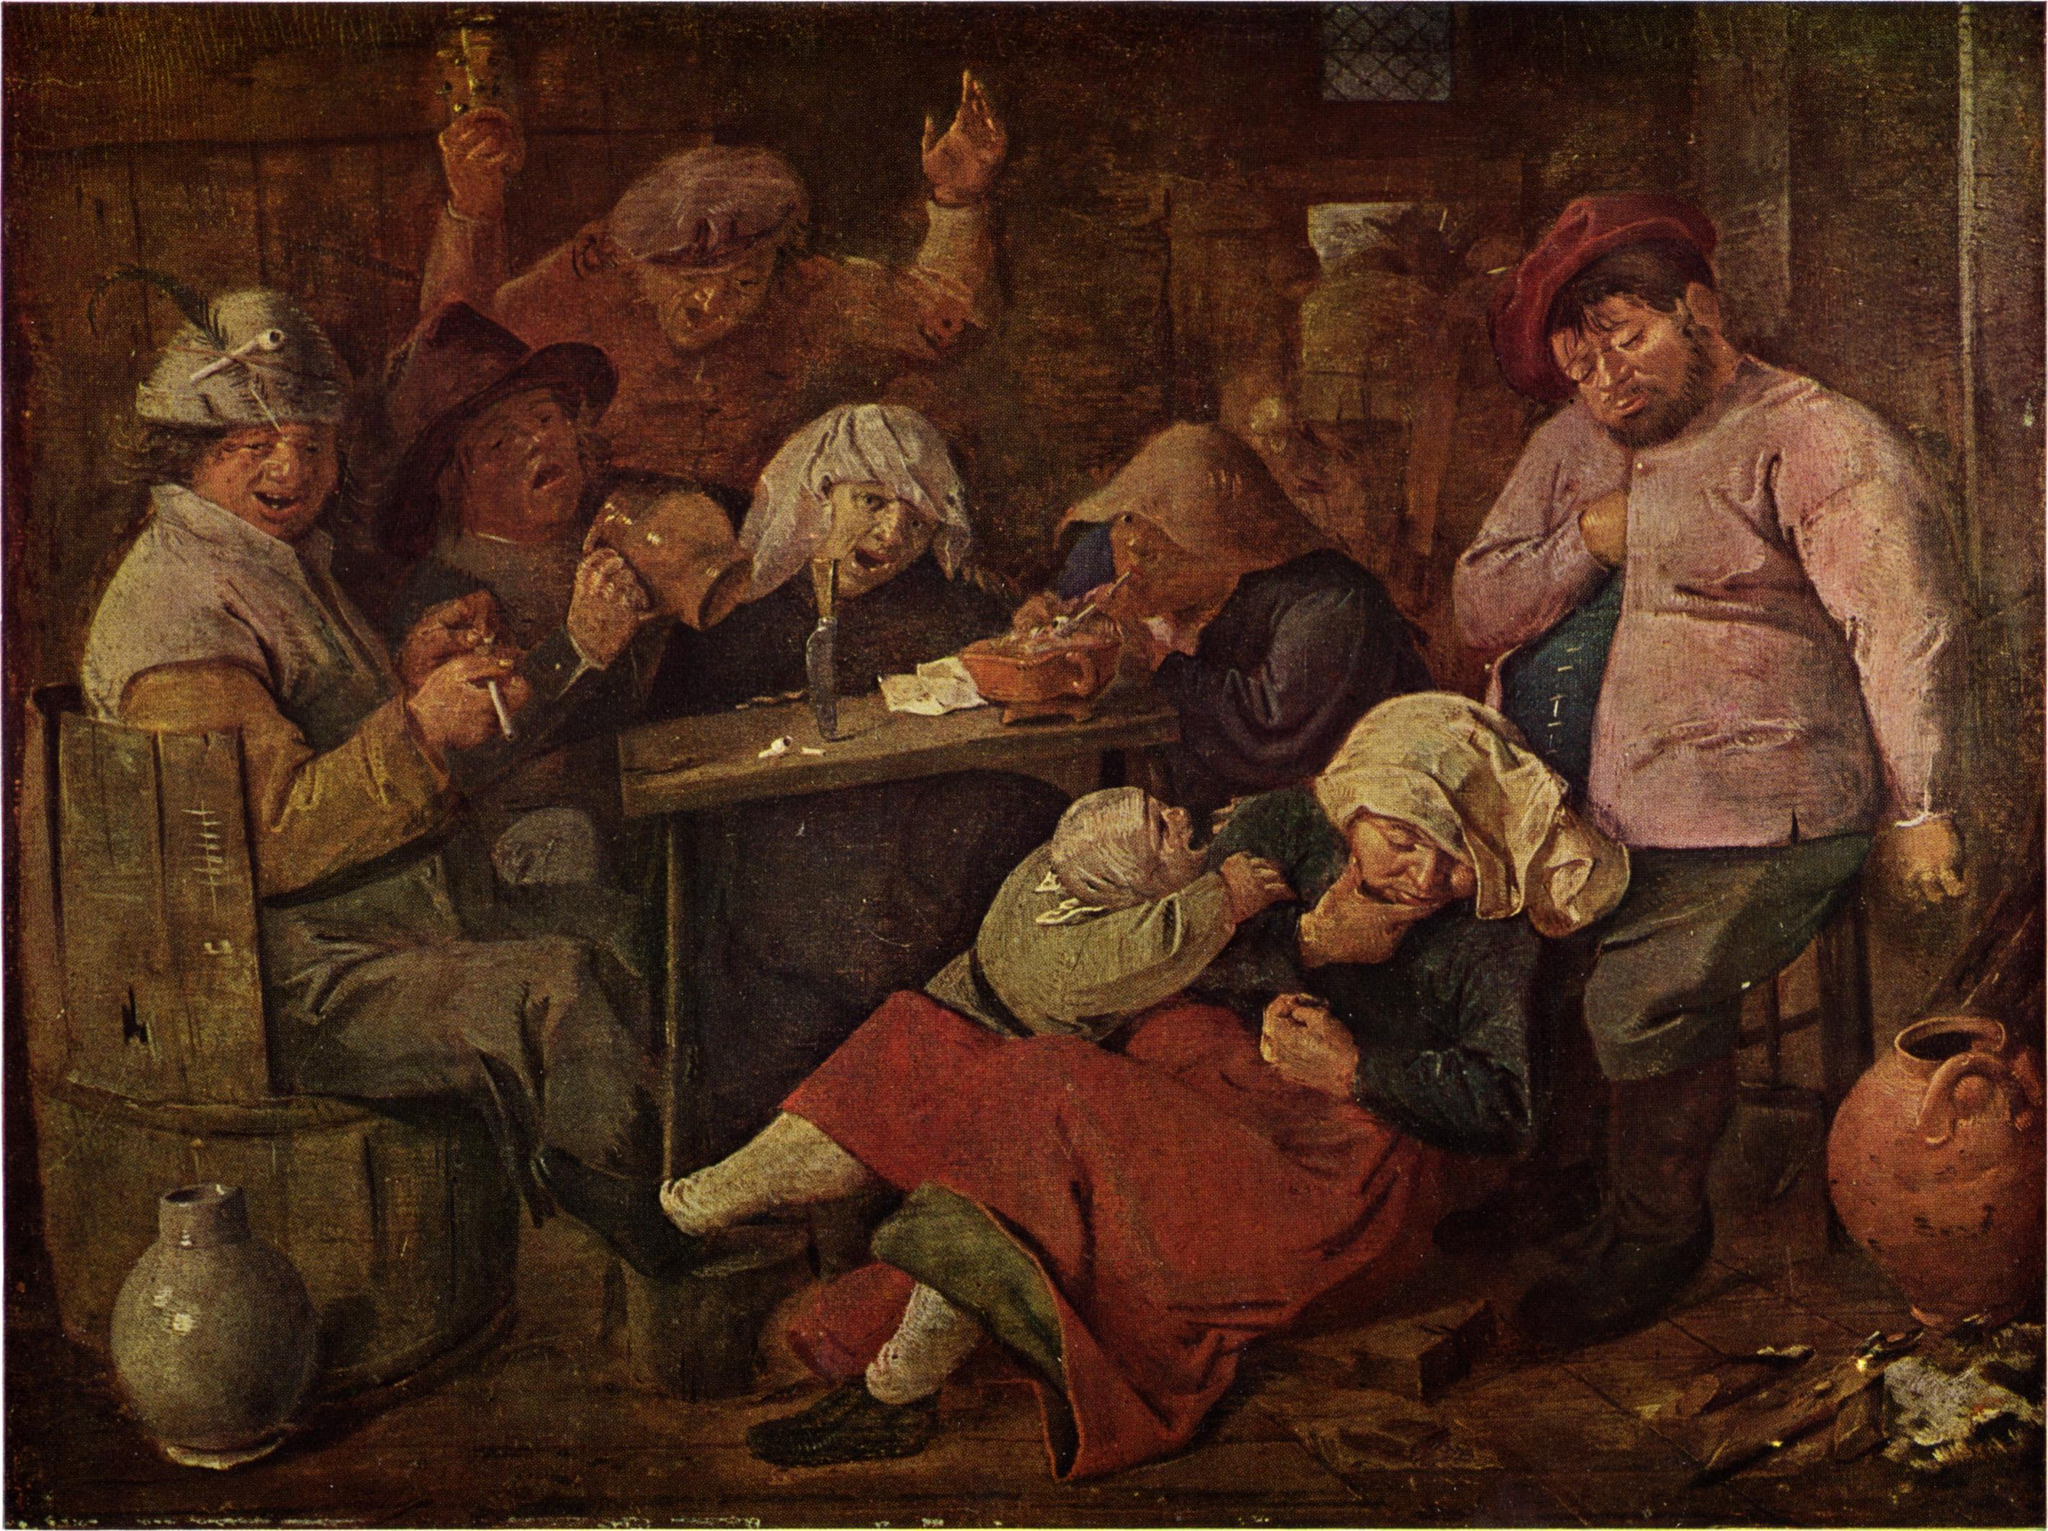What do you think is going on in this snapshot? The image is a rich, evocative oil painting from the Dutch Golden Age, capturing the essence of 17th-century daily life. The scene unfolds in a rustic tavern, where a group of lively characters is gathered around a table. Their attire, indicative of the era with its earthy tones and simple fabrics, adds authenticity to the scene. The individuals are engaged in timeless activities: drinking, smoking, and playing cards—leisurely pursuits that transcend time. The artist's use of a warm, earthy palette is punctuated by bold splashes of red and blue, bringing vibrancy to the scene. A single candle on the table dramatically illuminates the room, casting dynamic shadows and bringing the characters to life. The painting's attention to detail, the interplay of light and shadow, and the portrayal of ordinary people in their daily activities make it a fascinating glimpse into history, embodying the richness and aesthetic charm characteristic of Dutch Golden Age art. 